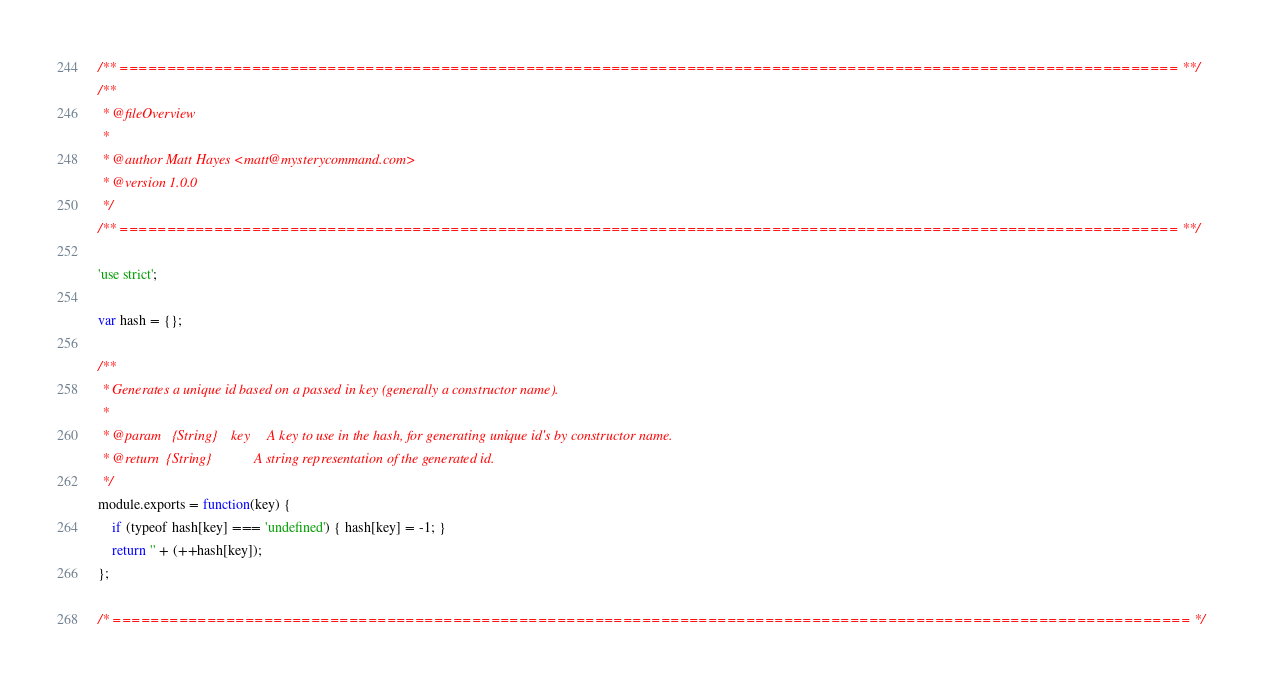<code> <loc_0><loc_0><loc_500><loc_500><_JavaScript_>/** ================================================================================================================ **/
/**
 * @fileOverview
 *
 * @author Matt Hayes <matt@mysterycommand.com>
 * @version 1.0.0
 */
/** ================================================================================================================ **/

'use strict';

var hash = {};

/**
 * Generates a unique id based on a passed in key (generally a constructor name).
 *
 * @param   {String}    key     A key to use in the hash, for generating unique id's by constructor name.
 * @return  {String}            A string representation of the generated id.
 */
module.exports = function(key) {
    if (typeof hash[key] === 'undefined') { hash[key] = -1; }
    return '' + (++hash[key]);
};

/* ================================================================================================================== */
</code> 